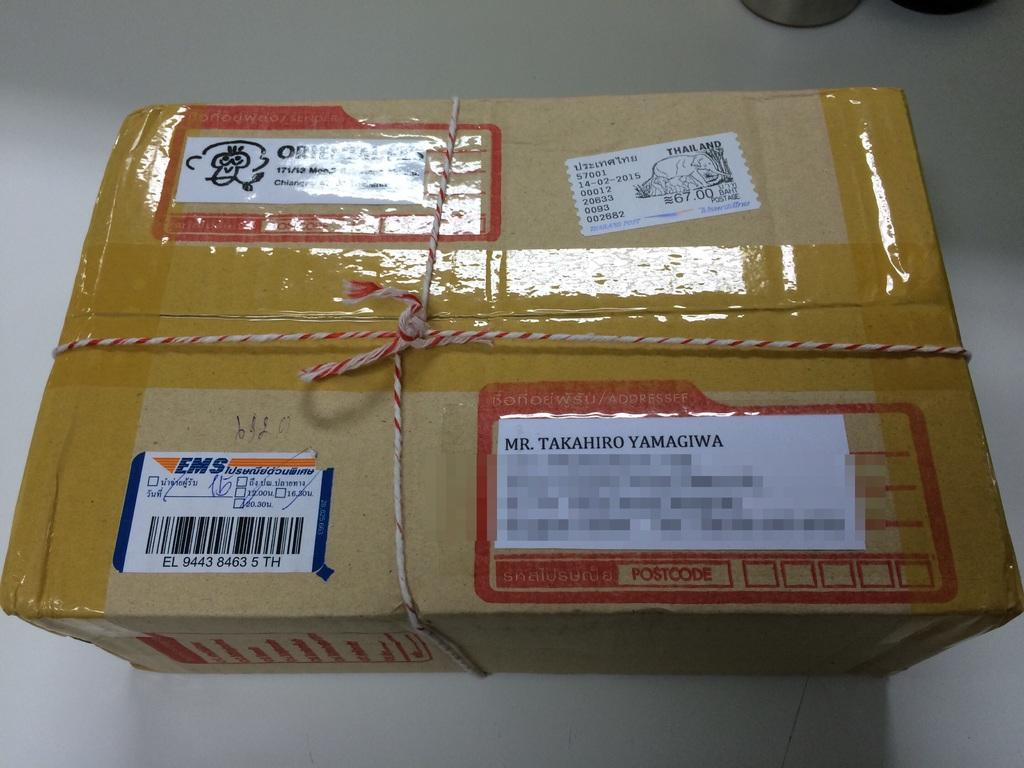Provide a one-sentence caption for the provided image. a box that is being shipped to mr. takahiro yamagiwa. 